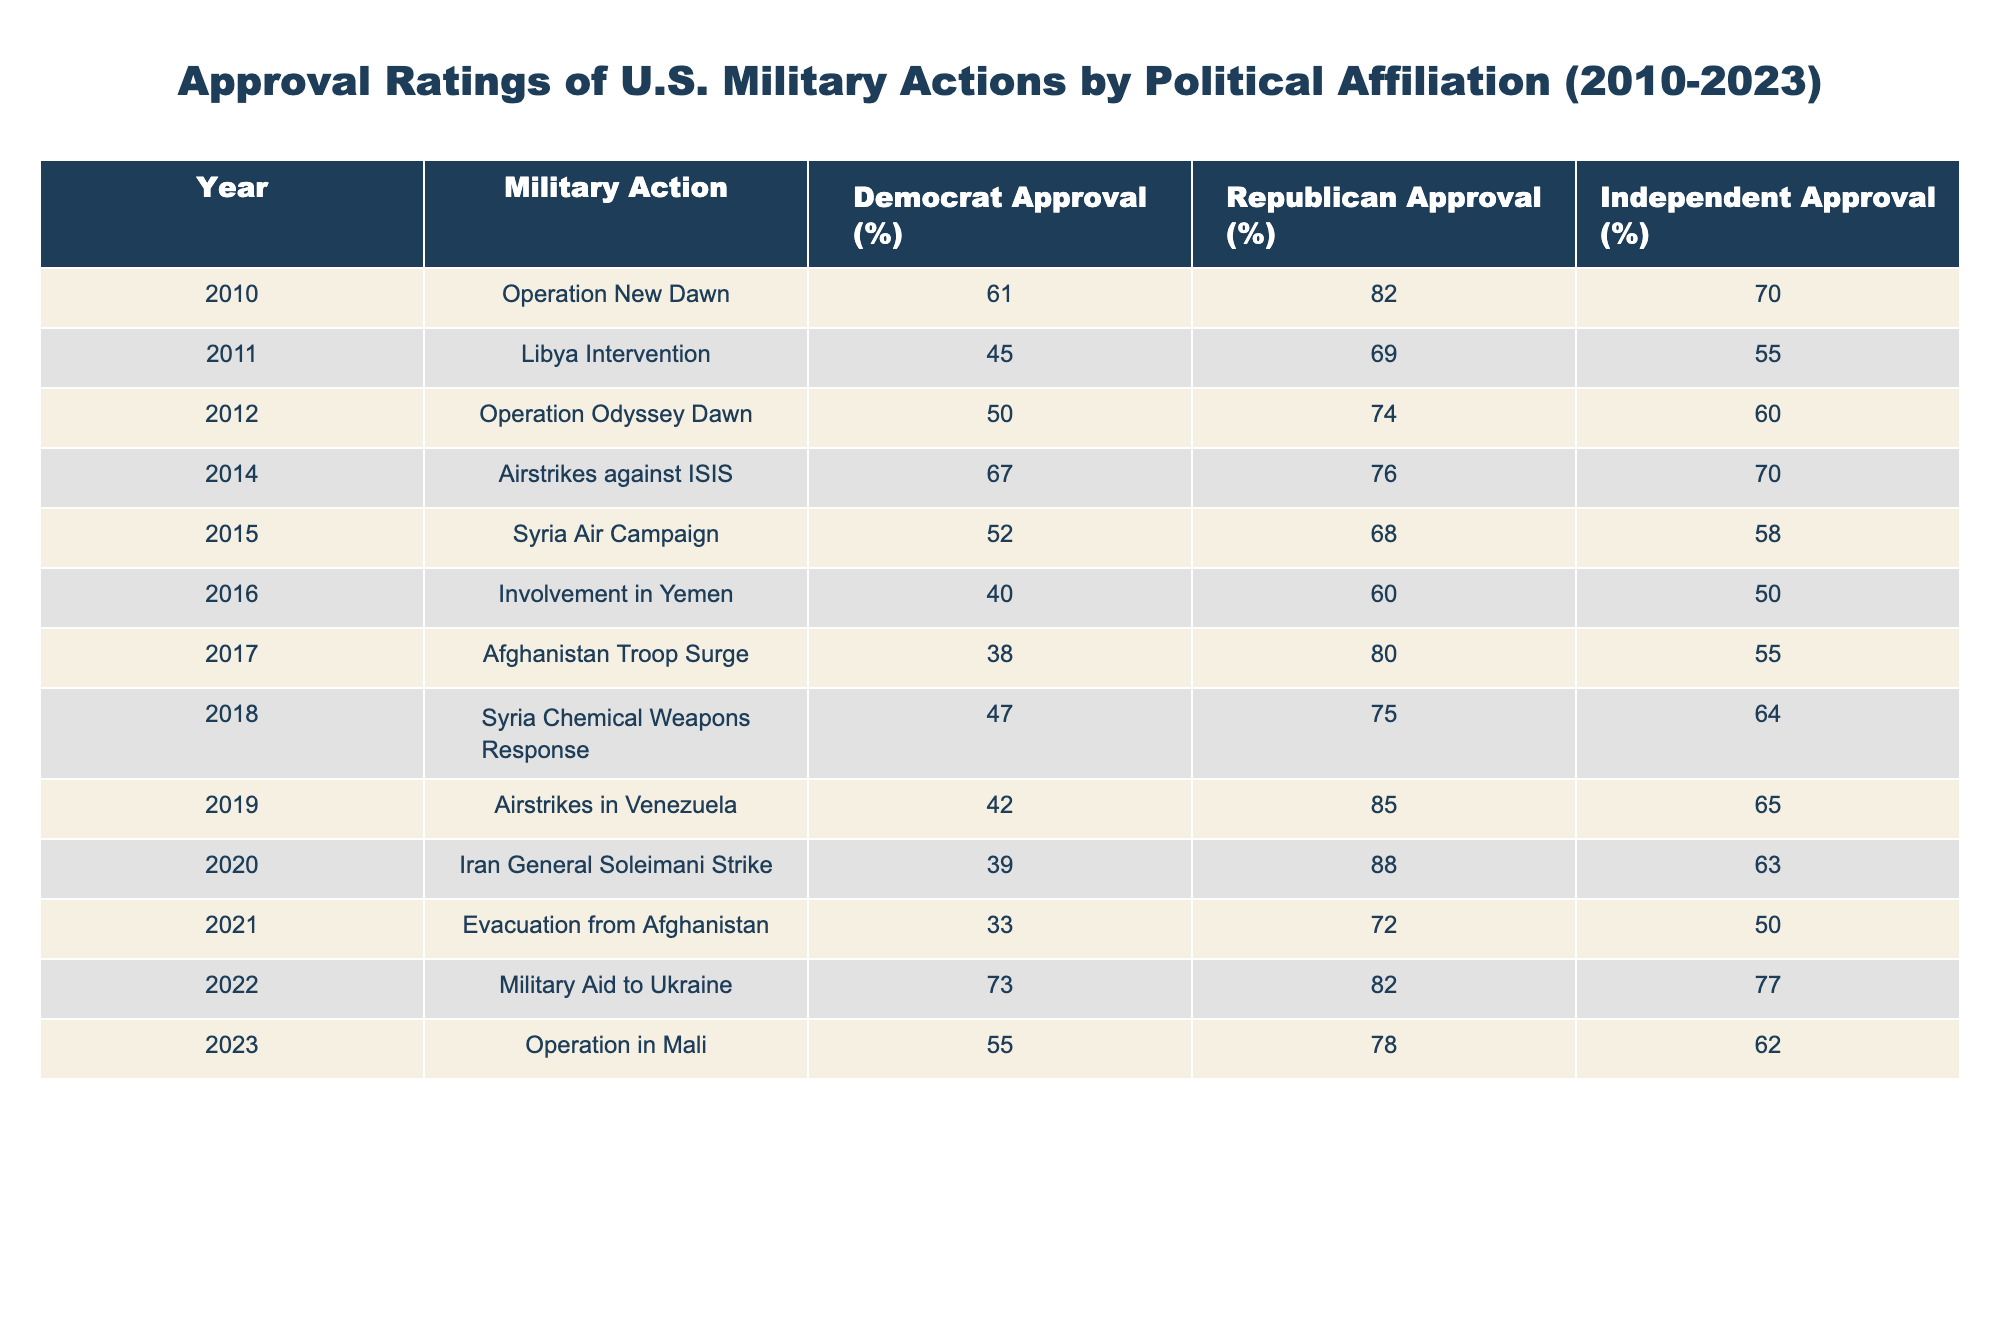What was the approval rating of Republicans for the Libya Intervention in 2011? The table shows that the approval rating for Republicans regarding the Libya Intervention in 2011 is 69%.
Answer: 69% What percentage of Independents approved of the Operation in Mali in 2023? According to the table, the approval rating for Independents for the Operation in Mali in 2023 is 62%.
Answer: 62% Which military action had the highest approval rating among Democrats from 2010 to 2023? Looking through the table, the highest approval rating among Democrats was for Military Aid to Ukraine in 2022, with a rating of 73%.
Answer: 73% What is the average approval rating of Democrats for all military actions listed? To find the average, sum the approval ratings for Democrats: (61 + 45 + 50 + 67 + 52 + 40 + 38 + 47 + 42 + 39 + 33 + 73 + 55) =  41.46. Then divide by the number of actions (13), which results in approximately 49.31%.
Answer: 49.31% Did the approval ratings for Republican Military Aid to Ukraine (2022) exceed 80%? The table indicates that the approval rating for Republicans regarding Military Aid to Ukraine in 2022 is 82%, which is greater than 80%.
Answer: Yes Which military action saw the greatest difference in approval ratings between Democrats and Republicans? To find this, look for the military action where the difference in approval ratings between Democrats and Republicans is the largest. For instance, in the Iran General Soleimani Strike (2020), Democrats had 39% and Republicans had 88%. The difference is 88 - 39 = 49%. This is the greatest difference found in the table.
Answer: 49% What percentage approval for the Afghanistan Troop Surge was higher, Democrats or Independents? From the table, the Democrats had an approval rating of 38% for the Afghanistan Troop Surge in 2017, while Independents had a rating of 55%. Since 55% is greater than 38%, Independents had a higher approval rating.
Answer: Independents What was the overall trend in Democrat approval ratings from 2010 to 2023? Analyzing the table shows fluctuations in Democrat approval ratings over the years. Starting at 61% in 2010, it dips significantly to 33% in 2021, rises again to 73% in 2022, and then down to 55% in 2023. This indicates a fluctuating trend rather than a consistent upward or downward pattern.
Answer: Fluctuating trend 